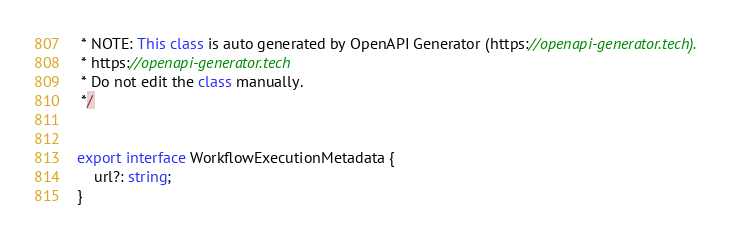Convert code to text. <code><loc_0><loc_0><loc_500><loc_500><_TypeScript_> * NOTE: This class is auto generated by OpenAPI Generator (https://openapi-generator.tech).
 * https://openapi-generator.tech
 * Do not edit the class manually.
 */


export interface WorkflowExecutionMetadata { 
    url?: string;
}

</code> 